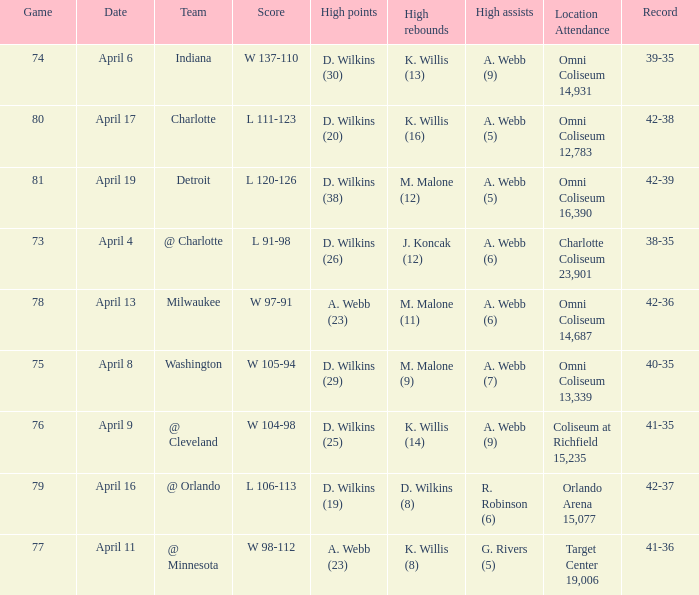What was the date of the game when g. rivers (5) had the  high assists? April 11. 